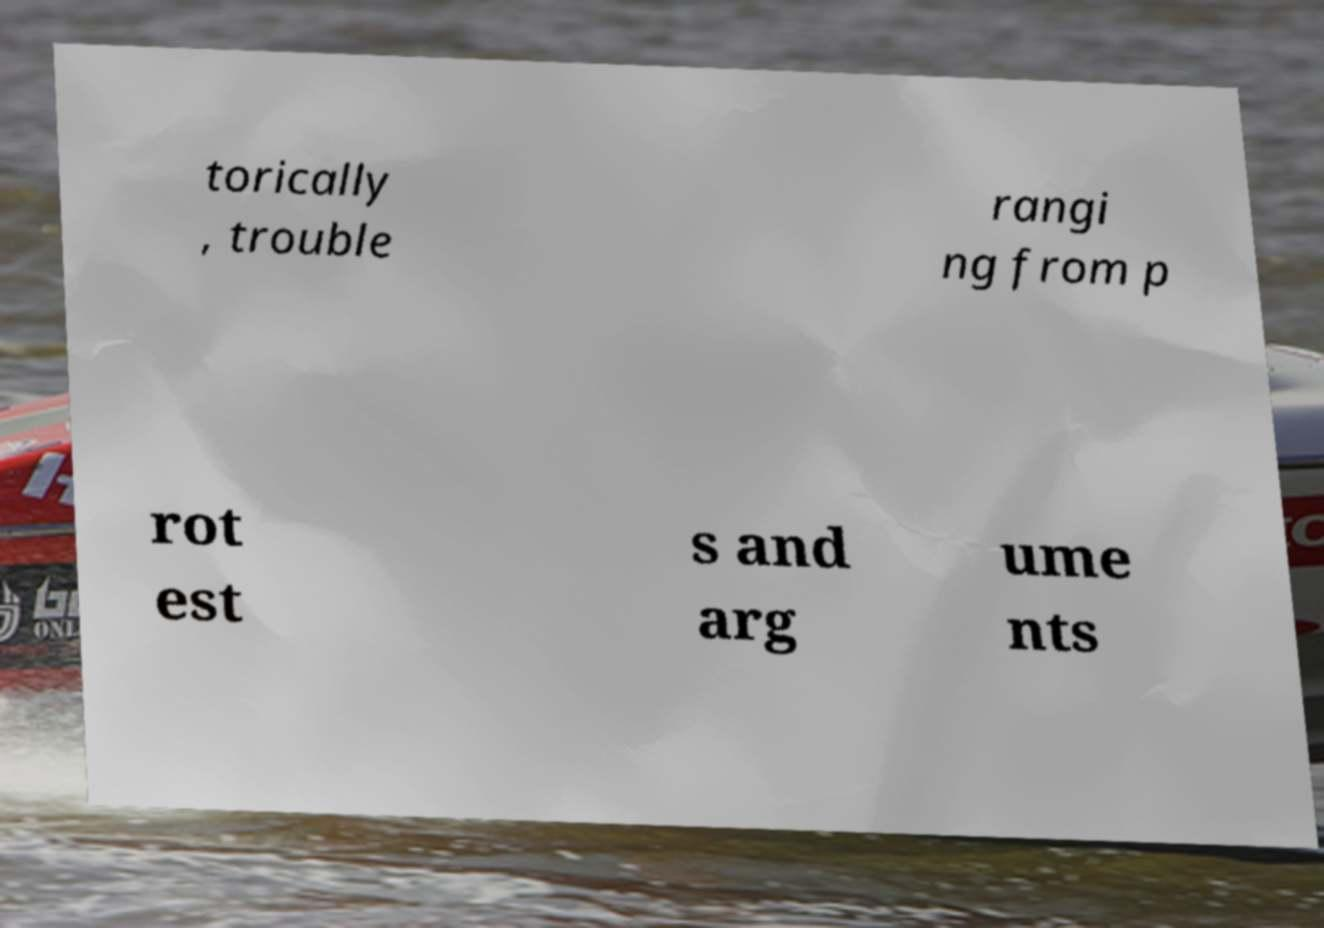Could you extract and type out the text from this image? torically , trouble rangi ng from p rot est s and arg ume nts 